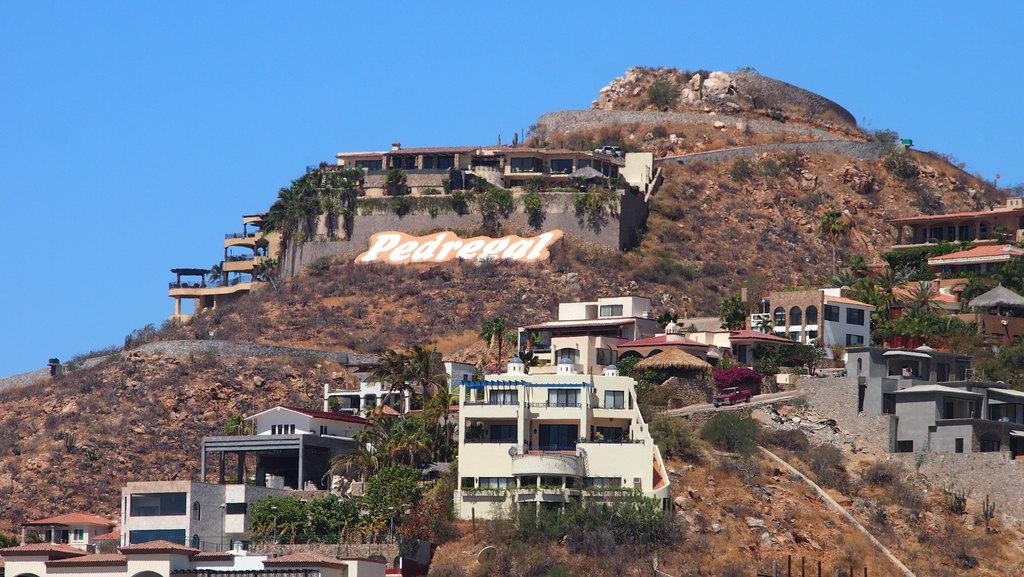Please provide a concise description of this image. In this image I can see a huge mountain in which I can see few buildings, few trees, few vehicles and in the background I can see the sky. 